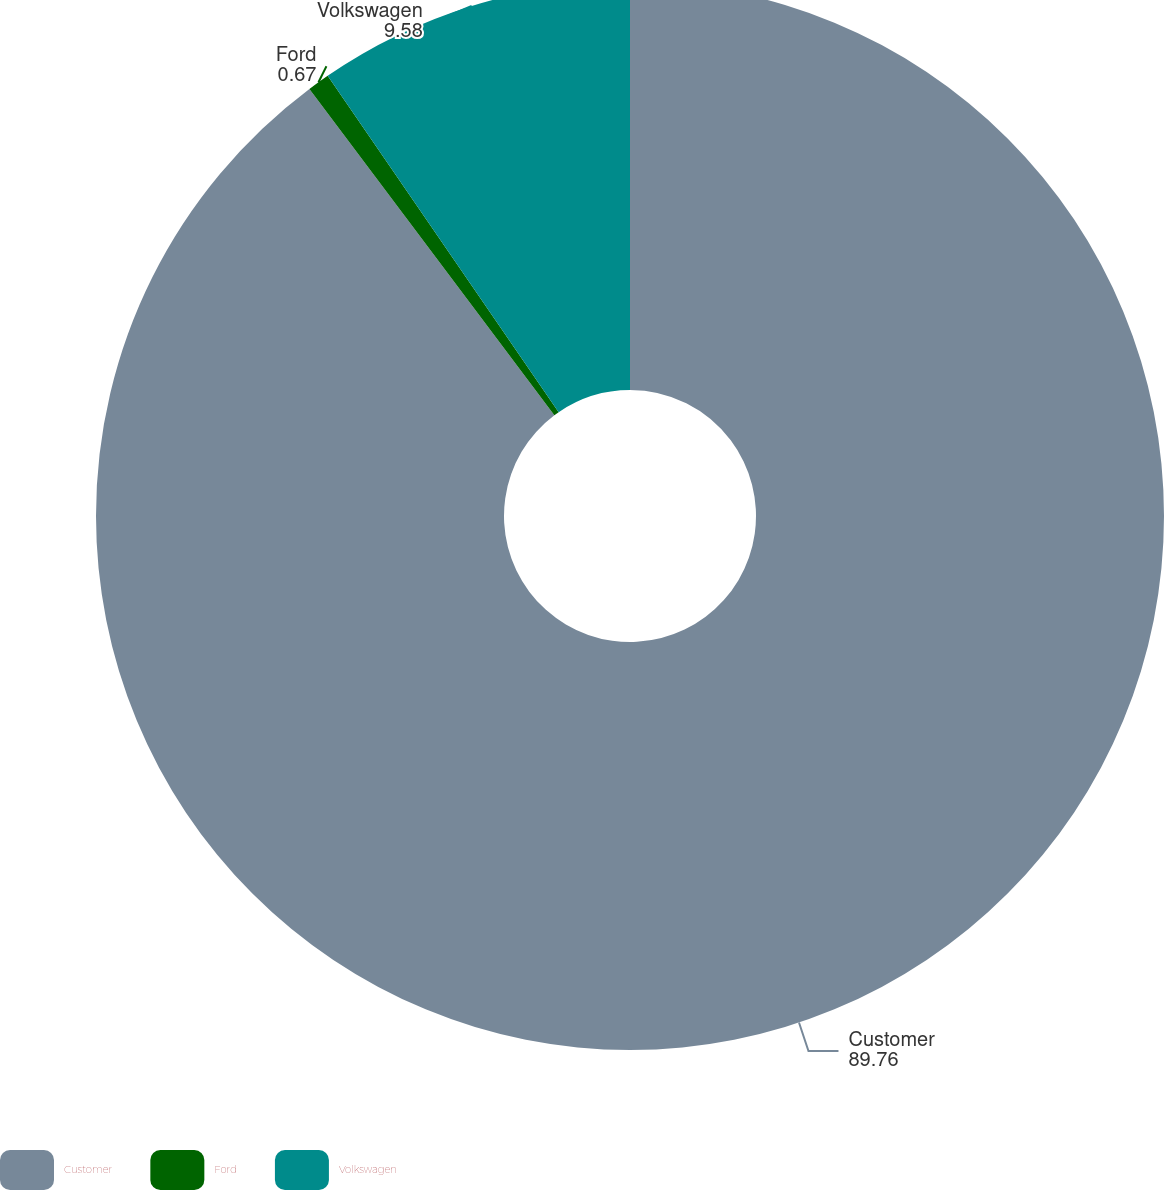Convert chart. <chart><loc_0><loc_0><loc_500><loc_500><pie_chart><fcel>Customer<fcel>Ford<fcel>Volkswagen<nl><fcel>89.76%<fcel>0.67%<fcel>9.58%<nl></chart> 